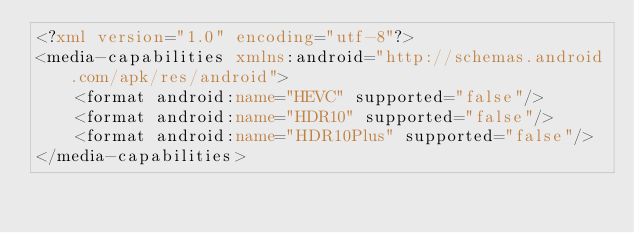Convert code to text. <code><loc_0><loc_0><loc_500><loc_500><_XML_><?xml version="1.0" encoding="utf-8"?>
<media-capabilities xmlns:android="http://schemas.android.com/apk/res/android">
    <format android:name="HEVC" supported="false"/>
    <format android:name="HDR10" supported="false"/>
    <format android:name="HDR10Plus" supported="false"/>
</media-capabilities></code> 